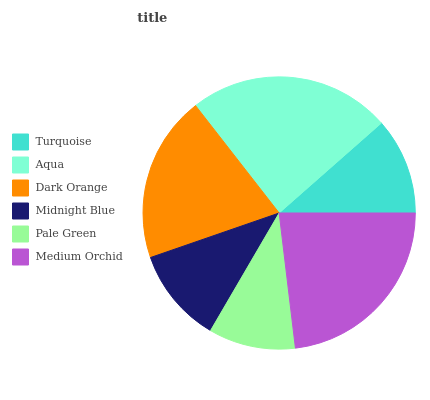Is Pale Green the minimum?
Answer yes or no. Yes. Is Aqua the maximum?
Answer yes or no. Yes. Is Dark Orange the minimum?
Answer yes or no. No. Is Dark Orange the maximum?
Answer yes or no. No. Is Aqua greater than Dark Orange?
Answer yes or no. Yes. Is Dark Orange less than Aqua?
Answer yes or no. Yes. Is Dark Orange greater than Aqua?
Answer yes or no. No. Is Aqua less than Dark Orange?
Answer yes or no. No. Is Dark Orange the high median?
Answer yes or no. Yes. Is Turquoise the low median?
Answer yes or no. Yes. Is Medium Orchid the high median?
Answer yes or no. No. Is Medium Orchid the low median?
Answer yes or no. No. 